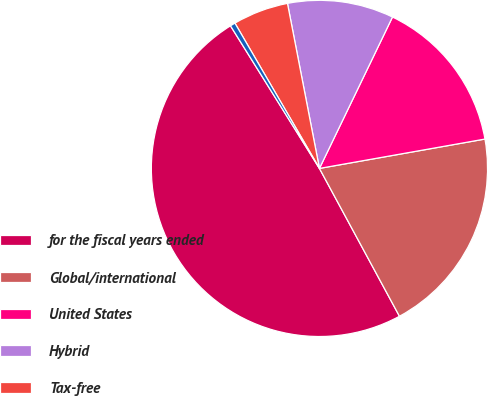<chart> <loc_0><loc_0><loc_500><loc_500><pie_chart><fcel>for the fiscal years ended<fcel>Global/international<fcel>United States<fcel>Hybrid<fcel>Tax-free<fcel>Cash Management<nl><fcel>49.02%<fcel>19.9%<fcel>15.05%<fcel>10.2%<fcel>5.34%<fcel>0.49%<nl></chart> 